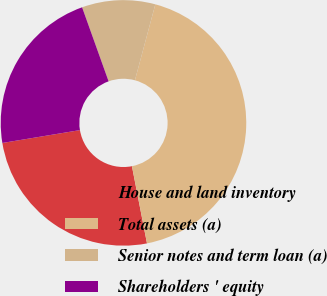<chart> <loc_0><loc_0><loc_500><loc_500><pie_chart><fcel>House and land inventory<fcel>Total assets (a)<fcel>Senior notes and term loan (a)<fcel>Shareholders ' equity<nl><fcel>25.45%<fcel>42.75%<fcel>9.65%<fcel>22.14%<nl></chart> 